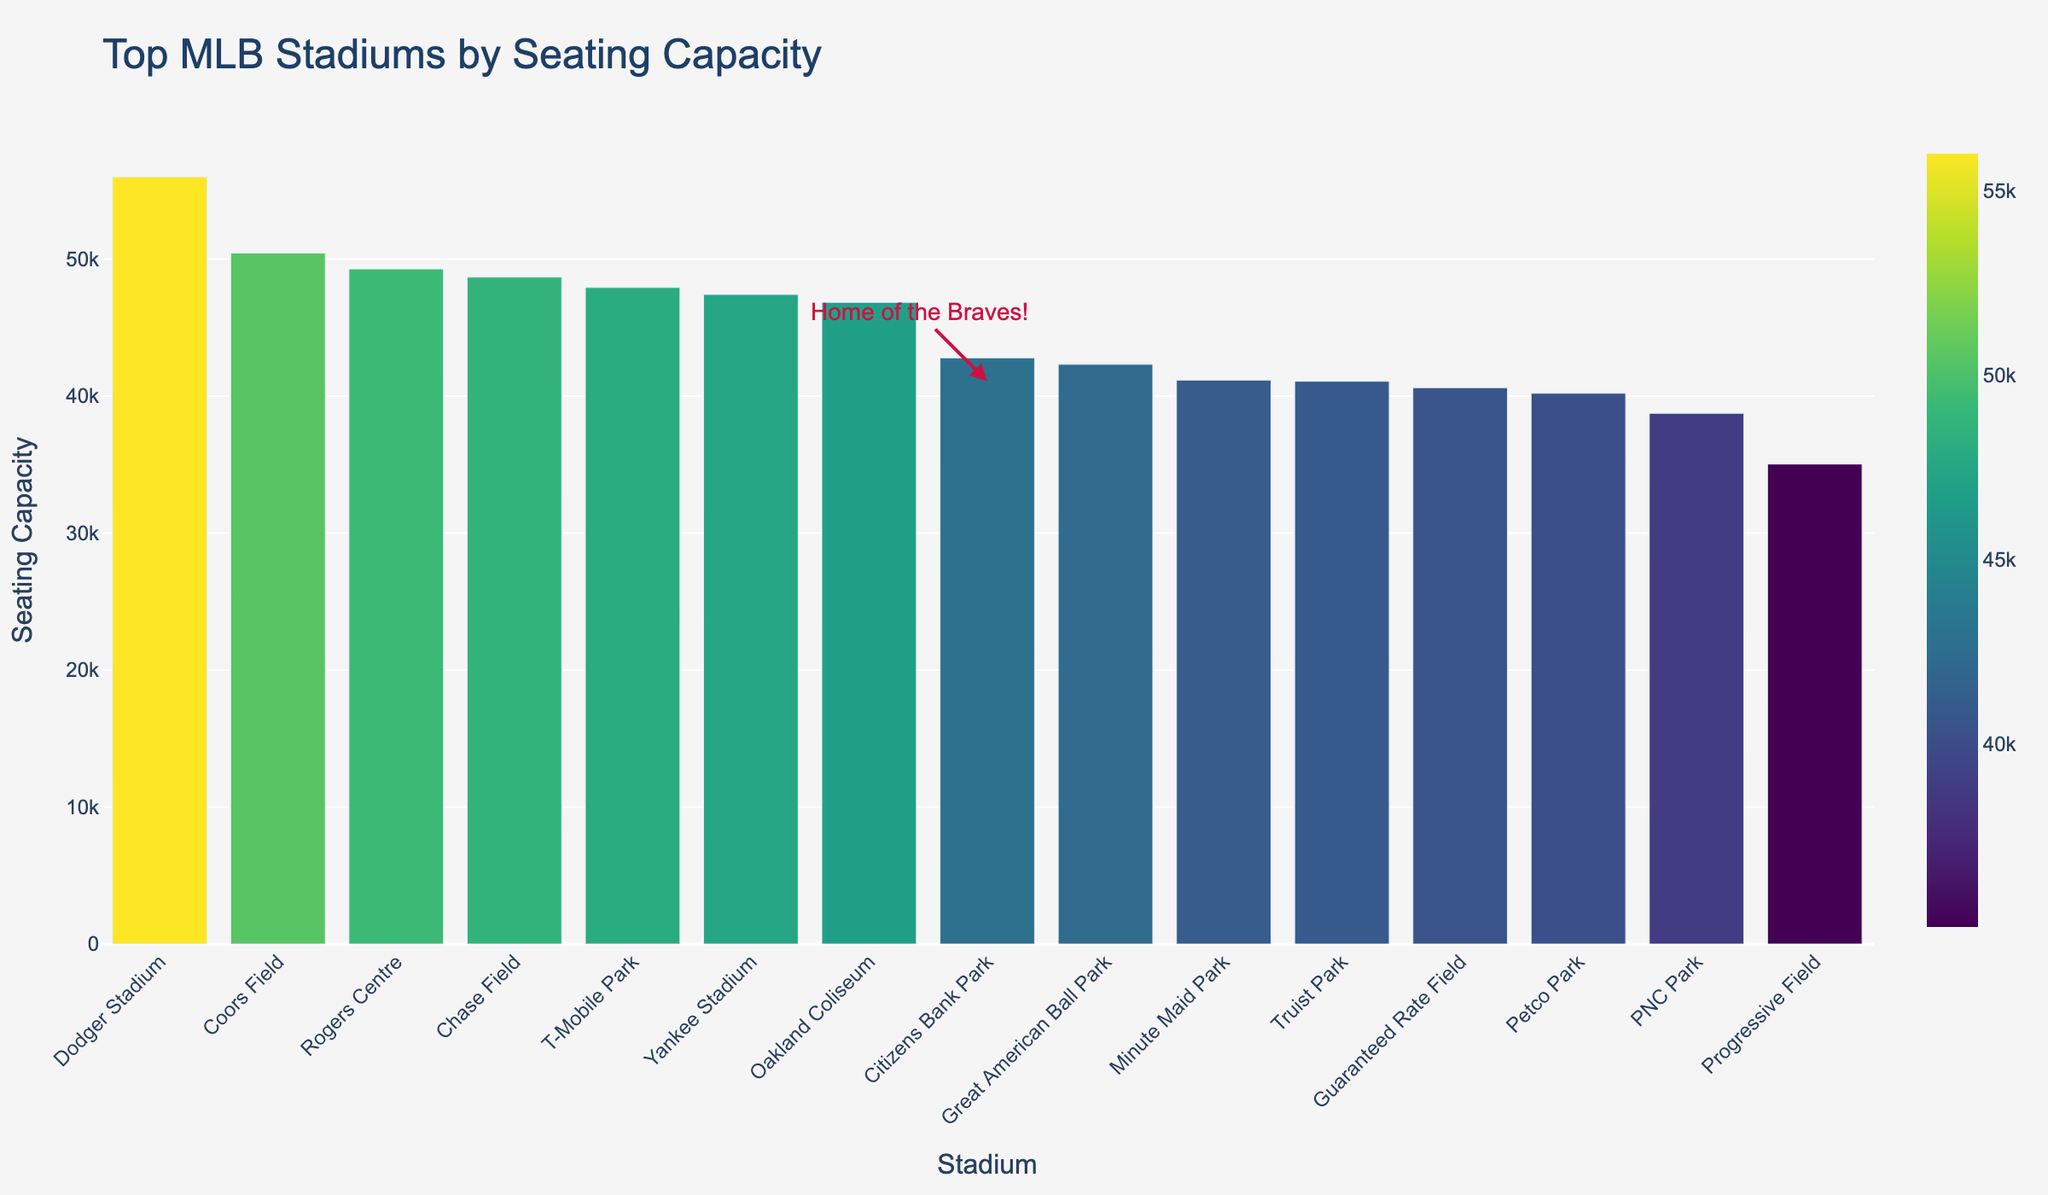What is the capacity of Dodger Stadium? The plot shows that Dodger Stadium has the highest seating capacity among the top 10 MLB stadiums. By reading the value on the bar, we see that the seating capacity is 56000.
Answer: 56000 Which stadium has a higher seating capacity: Chase Field or Yankee Stadium? By comparing the heights of the bars for Chase Field and Yankee Stadium, we see that Chase Field has a capacity of 48686 and Yankee Stadium has a capacity of 47422. Chase Field has a higher seating capacity.
Answer: Chase Field How much greater is the seating capacity of T-Mobile Park compared to Guaranteed Rate Field? From the bar chart, T-Mobile Park has a capacity of 47929 and Guaranteed Rate Field has a capacity of 40615. The difference is 47929 - 40615 = 7314.
Answer: 7314 What is the combined seating capacity of Coors Field and Rogers Centre? Coors Field has a capacity of 50445 and Rogers Centre has a capacity of 49282. The combined capacity is 50445 + 49282 = 99727.
Answer: 99727 How does the seating capacity of Truist Park compare visually to other stadiums in the Top 10? The bar for Truist Park is shorter than those of the other listed stadiums except for Guaranteed Rate Field. This visually indicates that Truist Park is towards the lower end of the top 10 stadiums by seating capacity. Truist Park's capacity is 41084.
Answer: Truist Park has a lower capacity compared to most in the top 10 Which stadium has the lowest seating capacity in the top 10? By looking at the heights of the bars, the smallest one corresponds to Guaranteed Rate Field, with a seating capacity of 40615.
Answer: Guaranteed Rate Field What is the sum of the seating capacities for all top 10 MLB stadiums shown in the figure? Adding the capacities: 56000 (Dodger) + 50445 (Coors) + 49282 (Rogers) + 48686 (Chase) + 47929 (T-Mobile) + 47422 (Yankee) + 46847 (Oakland) + 42792 (Citizens Bank) + 42319 (Great American) + 41084 (Truist) = 462806
Answer: 462806 